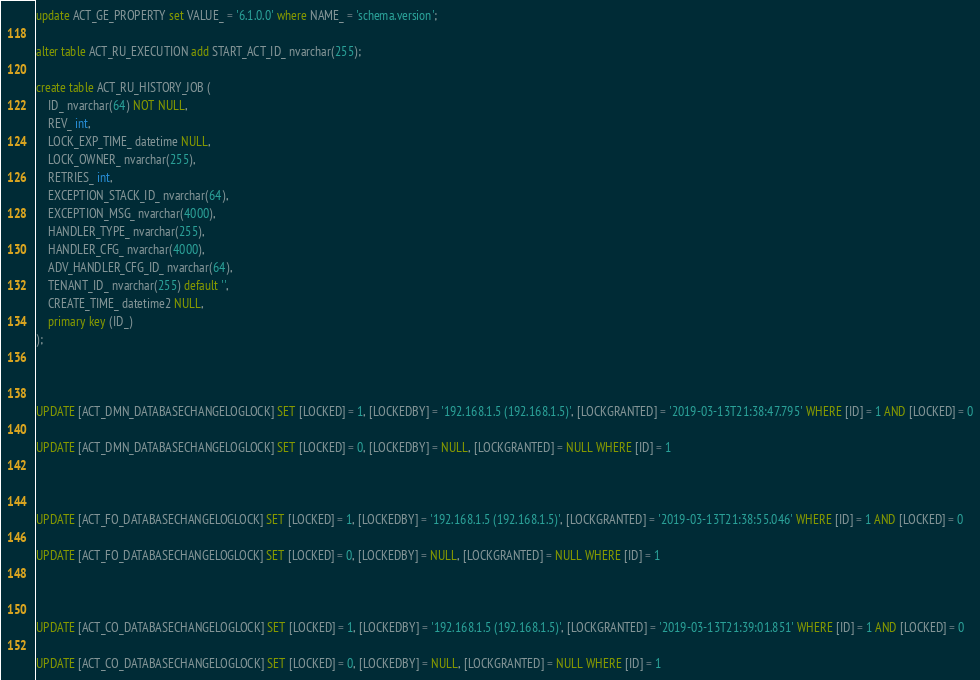<code> <loc_0><loc_0><loc_500><loc_500><_SQL_>update ACT_GE_PROPERTY set VALUE_ = '6.1.0.0' where NAME_ = 'schema.version';

alter table ACT_RU_EXECUTION add START_ACT_ID_ nvarchar(255);

create table ACT_RU_HISTORY_JOB (
    ID_ nvarchar(64) NOT NULL,
    REV_ int,
    LOCK_EXP_TIME_ datetime NULL,
    LOCK_OWNER_ nvarchar(255),
    RETRIES_ int,
    EXCEPTION_STACK_ID_ nvarchar(64),
    EXCEPTION_MSG_ nvarchar(4000),
    HANDLER_TYPE_ nvarchar(255),
    HANDLER_CFG_ nvarchar(4000),
    ADV_HANDLER_CFG_ID_ nvarchar(64),
    TENANT_ID_ nvarchar(255) default '',
    CREATE_TIME_ datetime2 NULL,
    primary key (ID_)
);



UPDATE [ACT_DMN_DATABASECHANGELOGLOCK] SET [LOCKED] = 1, [LOCKEDBY] = '192.168.1.5 (192.168.1.5)', [LOCKGRANTED] = '2019-03-13T21:38:47.795' WHERE [ID] = 1 AND [LOCKED] = 0

UPDATE [ACT_DMN_DATABASECHANGELOGLOCK] SET [LOCKED] = 0, [LOCKEDBY] = NULL, [LOCKGRANTED] = NULL WHERE [ID] = 1



UPDATE [ACT_FO_DATABASECHANGELOGLOCK] SET [LOCKED] = 1, [LOCKEDBY] = '192.168.1.5 (192.168.1.5)', [LOCKGRANTED] = '2019-03-13T21:38:55.046' WHERE [ID] = 1 AND [LOCKED] = 0

UPDATE [ACT_FO_DATABASECHANGELOGLOCK] SET [LOCKED] = 0, [LOCKEDBY] = NULL, [LOCKGRANTED] = NULL WHERE [ID] = 1



UPDATE [ACT_CO_DATABASECHANGELOGLOCK] SET [LOCKED] = 1, [LOCKEDBY] = '192.168.1.5 (192.168.1.5)', [LOCKGRANTED] = '2019-03-13T21:39:01.851' WHERE [ID] = 1 AND [LOCKED] = 0

UPDATE [ACT_CO_DATABASECHANGELOGLOCK] SET [LOCKED] = 0, [LOCKEDBY] = NULL, [LOCKGRANTED] = NULL WHERE [ID] = 1

</code> 